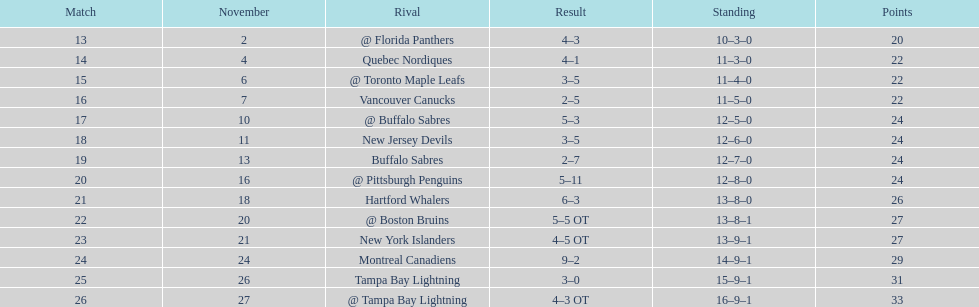Who had the most assists on the 1993-1994 flyers? Mark Recchi. 